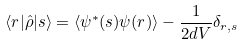Convert formula to latex. <formula><loc_0><loc_0><loc_500><loc_500>\langle r | \hat { \rho } | s \rangle = \langle { \psi } ^ { * } ( s ) \psi ( r ) \rangle - \frac { 1 } { 2 d V } \delta _ { r , s }</formula> 